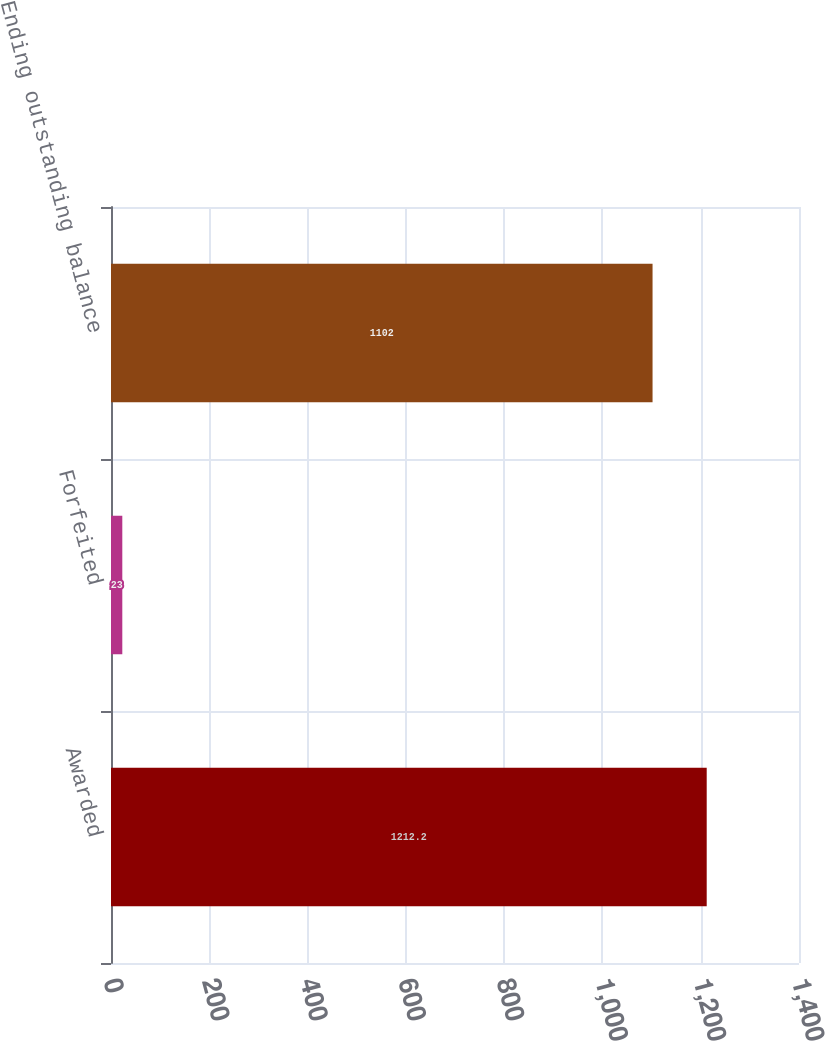Convert chart. <chart><loc_0><loc_0><loc_500><loc_500><bar_chart><fcel>Awarded<fcel>Forfeited<fcel>Ending outstanding balance<nl><fcel>1212.2<fcel>23<fcel>1102<nl></chart> 